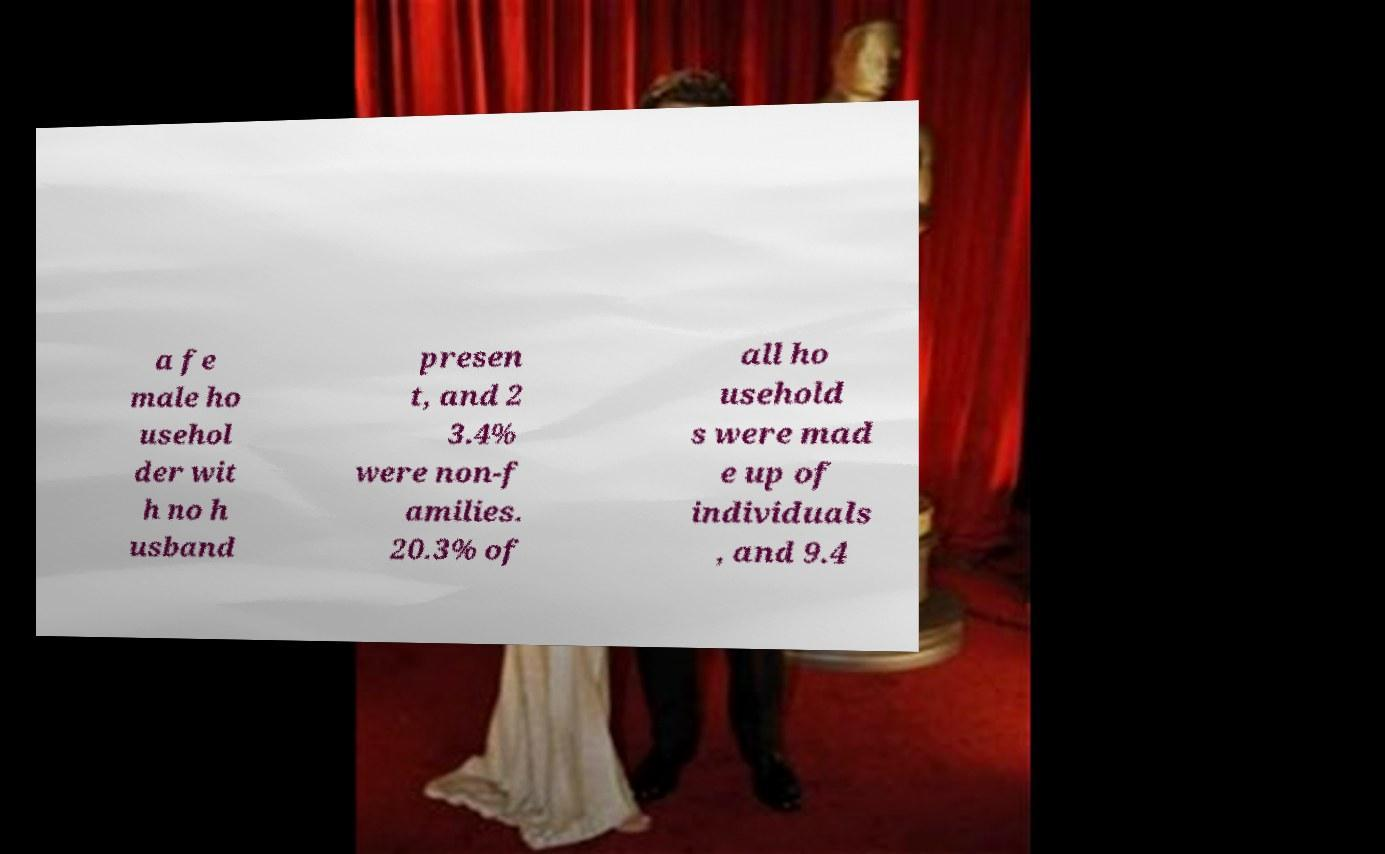For documentation purposes, I need the text within this image transcribed. Could you provide that? a fe male ho usehol der wit h no h usband presen t, and 2 3.4% were non-f amilies. 20.3% of all ho usehold s were mad e up of individuals , and 9.4 